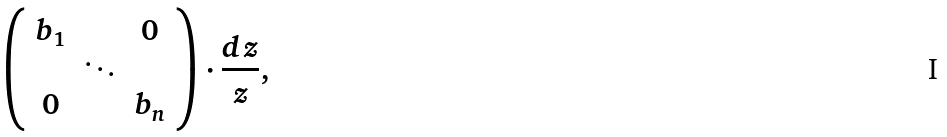Convert formula to latex. <formula><loc_0><loc_0><loc_500><loc_500>\left ( \begin{array} { c c c c } b _ { 1 } & & 0 \\ & \ddots & \\ 0 & & b _ { n } \end{array} \right ) \cdot { \frac { d z } { z } } ,</formula> 